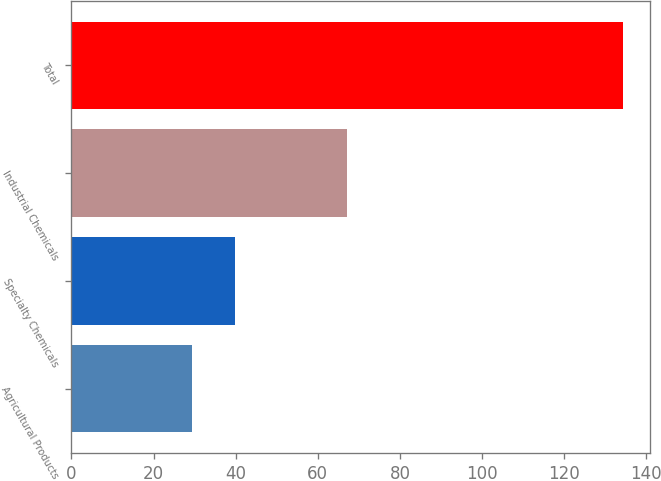Convert chart to OTSL. <chart><loc_0><loc_0><loc_500><loc_500><bar_chart><fcel>Agricultural Products<fcel>Specialty Chemicals<fcel>Industrial Chemicals<fcel>Total<nl><fcel>29.3<fcel>39.8<fcel>67<fcel>134.3<nl></chart> 